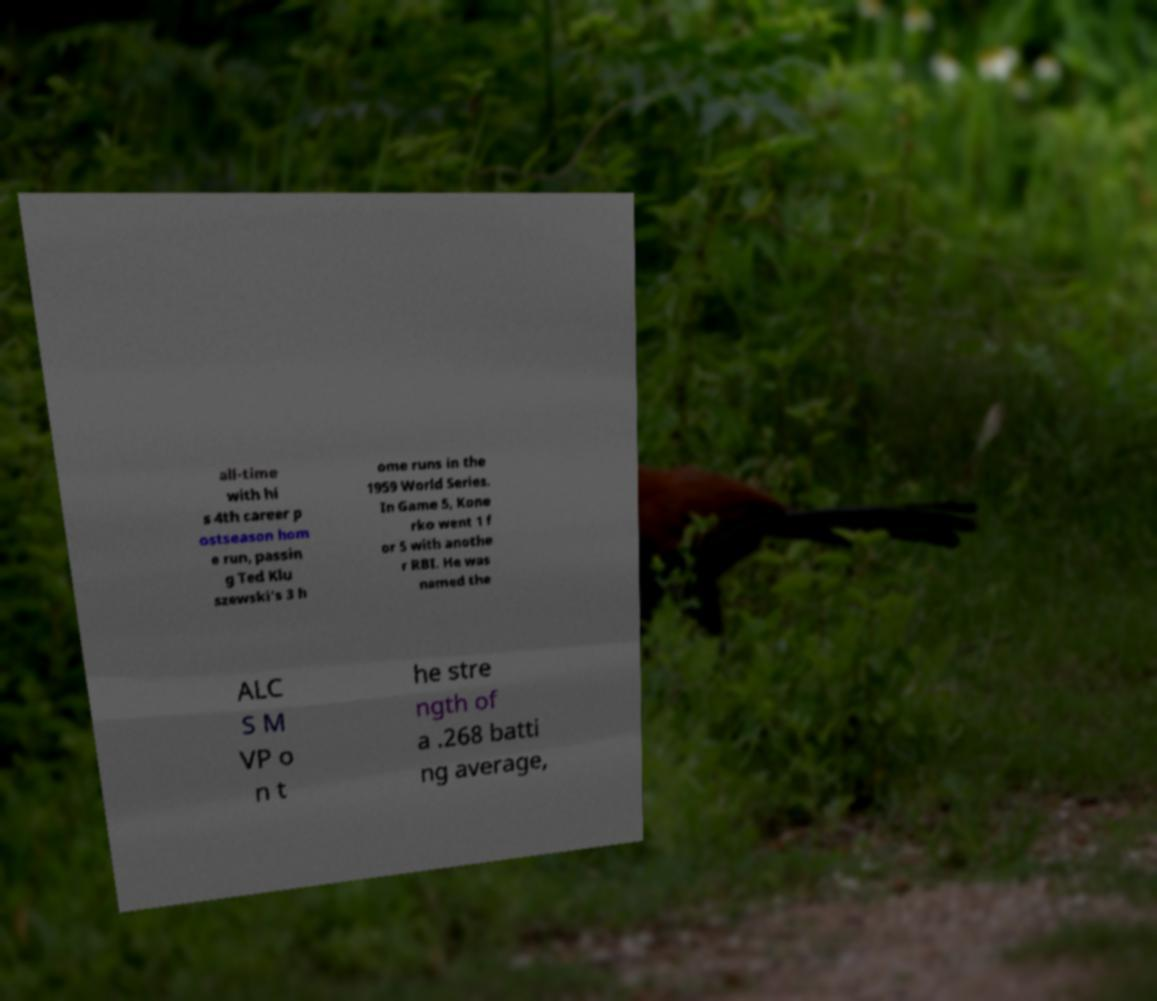Can you accurately transcribe the text from the provided image for me? all-time with hi s 4th career p ostseason hom e run, passin g Ted Klu szewski's 3 h ome runs in the 1959 World Series. In Game 5, Kone rko went 1 f or 5 with anothe r RBI. He was named the ALC S M VP o n t he stre ngth of a .268 batti ng average, 